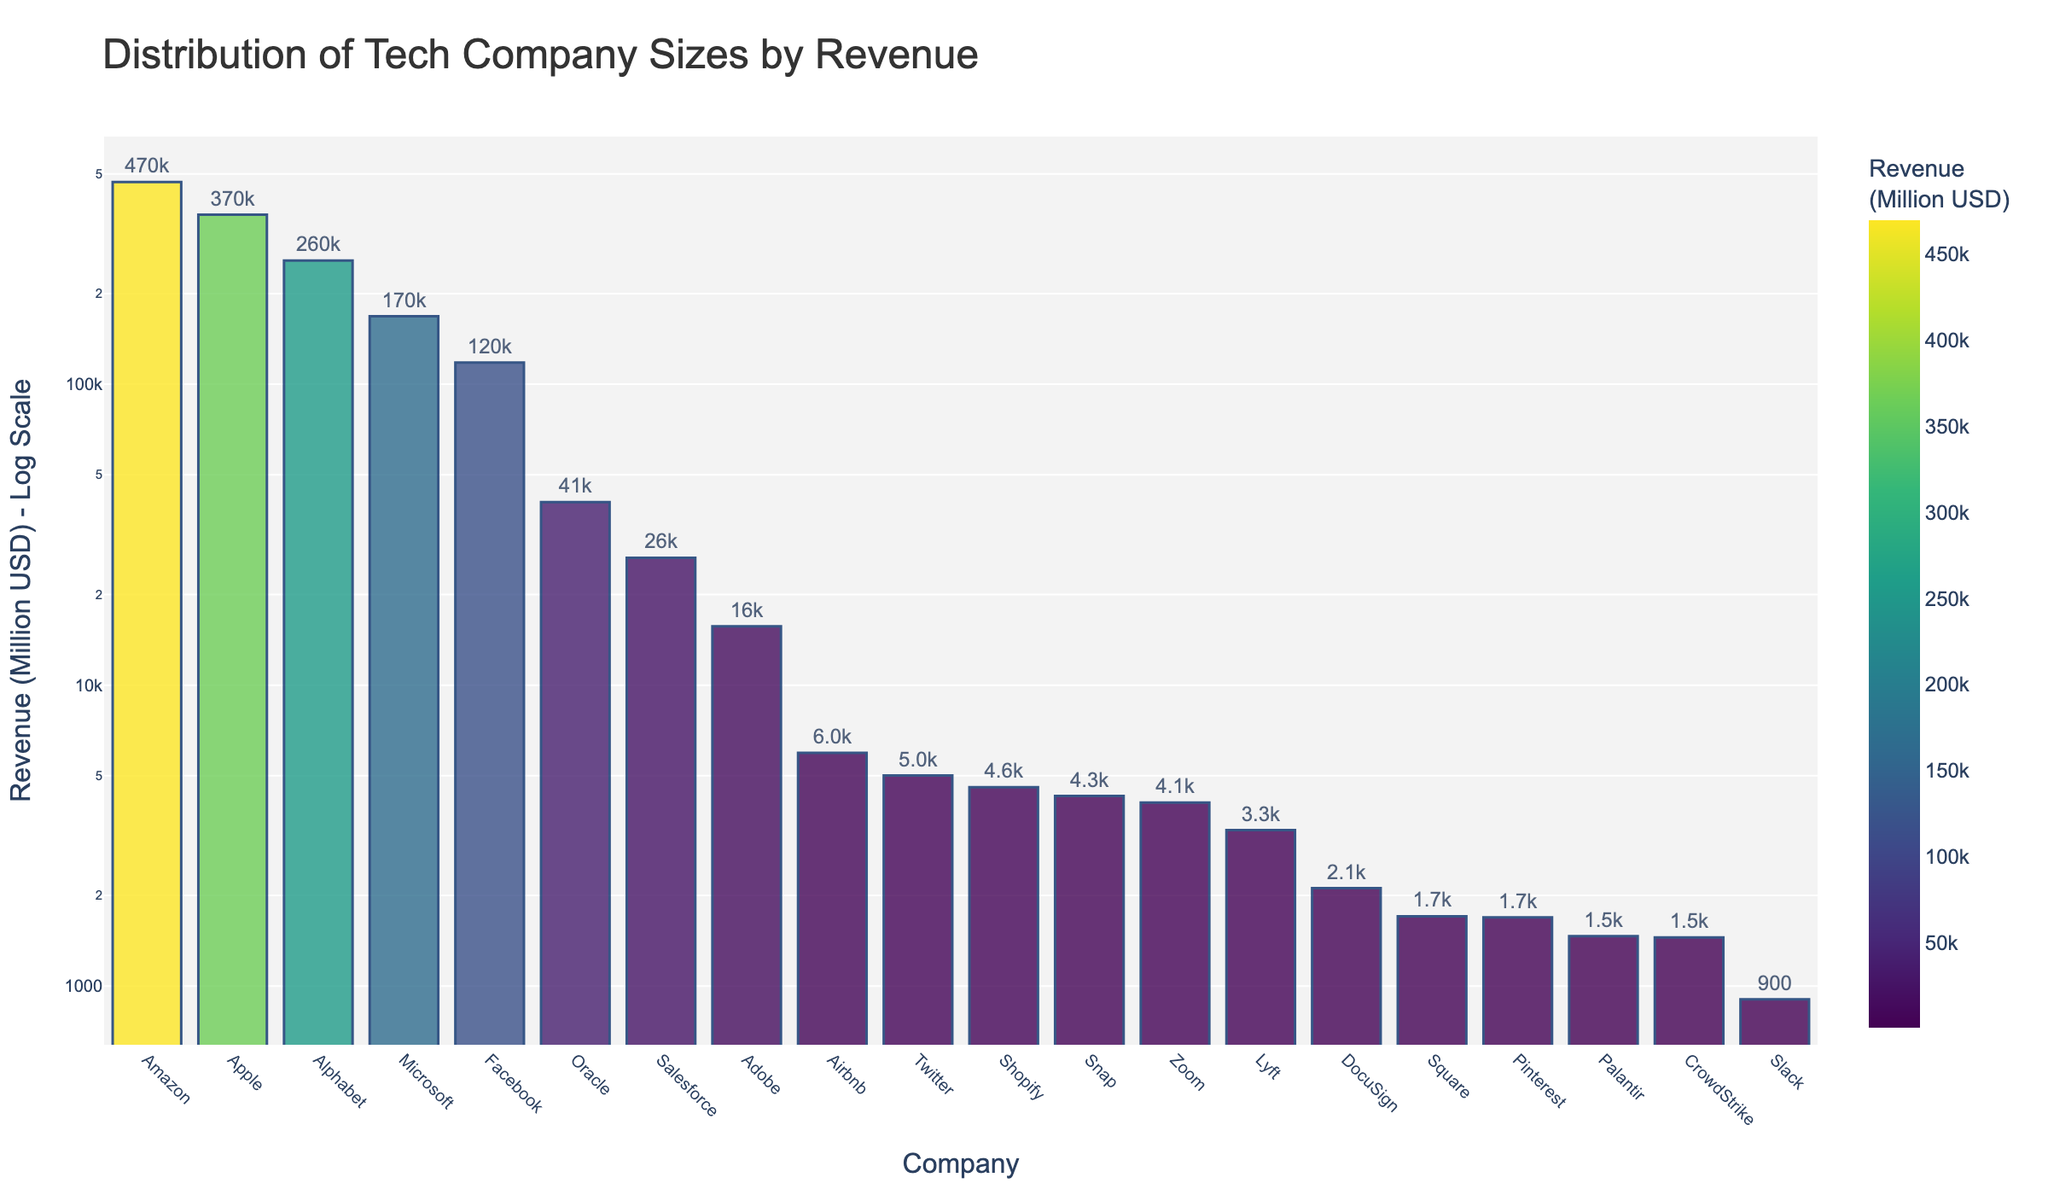What is the title of the chart? The title of the chart is written at the top and provides a brief description of what the chart is about. In this case, it mentions the tech industry and the metric being measured.
Answer: Distribution of Tech Company Sizes by Revenue Which company has the highest revenue? The company with the highest revenue will have the tallest bar in the chart, which is color-coded as the darkest shade in the color scale used.
Answer: Amazon How many companies have a revenue greater than 100,000 million USD? Each bar represents a company, and since the y-axis is on a log scale, you need to identify the bars that are positioned higher than the 100,000 million USD mark on the log scale.
Answer: 4 What is the approximate revenue of Salesforce in million USD? Look for the bar corresponding to Salesforce and read the value from the y-axis. Given that the y-axis is on a log scale, approximate where the bar falls on this scale.
Answer: Approximately 26,492 Which company has a revenue closest to 10,000 million USD? Locate the bar that is closest to the 10,000 million USD mark on the y-axis. Compare the bars' heights that are near the 10,000 million USD line.
Answer: Adobe How does the revenue of Facebook compare to that of Microsoft? Identify the bars representing Facebook and Microsoft. Compare their heights directly or look at the y-axis values they correspond to.
Answer: Microsoft has a higher revenue than Facebook What is the difference in revenue between the highest and the lowest company on the chart? Find the revenue of Amazon (the highest revenue) and Slack (the lowest revenue). Calculate the difference between these two values.
Answer: 469822 - 903 = 468,919 million USD Which companies have revenue between 3,000 million USD and 7,000 million USD? On the log scale y-axis, identify the range between 3,000 million USD and 7,000 million USD. The bars that fall within this range represent the companies of interest.
Answer: Zoom, Lyft, Palantir, CrowdStrike, Square, DocuSign Is Salesforce's revenue higher or lower than Oracle's? Locate the bars for Salesforce and Oracle. Compare their heights or read off the log-scaled y-axis.
Answer: Lower What is the median revenue value from the listed companies? Arrange the revenues in ascending order and find the middle value to determine the median. Since there are 20 companies, the median will be the average of the 10th and 11th values.
Answer: Approximately 2,706.5 million USD 